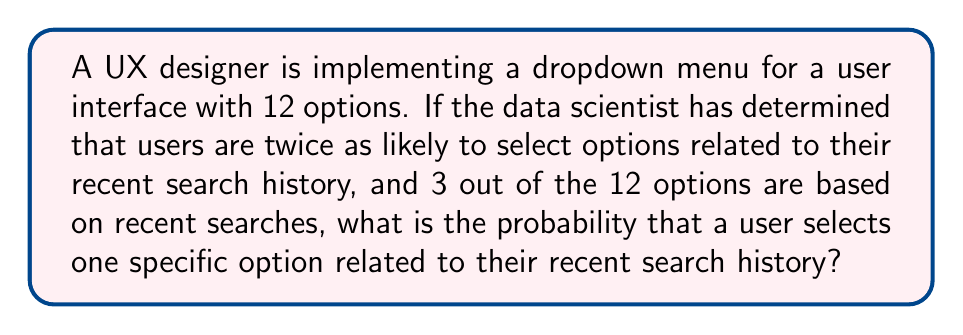Can you solve this math problem? Let's approach this step-by-step:

1) First, we need to calculate the total probability weight of all options:
   - 9 regular options: $9 \times 1 = 9$
   - 3 recent search options: $3 \times 2 = 6$
   - Total weight: $9 + 6 = 15$

2) The probability of selecting any option is its weight divided by the total weight:
   - For a regular option: $\frac{1}{15}$
   - For a recent search option: $\frac{2}{15}$

3) We're asked about the probability of selecting one specific recent search option:
   $$P(\text{specific recent search option}) = \frac{2}{15}$$

4) To verify, we can check that all probabilities sum to 1:
   $$9 \times \frac{1}{15} + 3 \times \frac{2}{15} = \frac{9}{15} + \frac{6}{15} = 1$$

Therefore, the probability of selecting one specific option related to recent search history is $\frac{2}{15}$.
Answer: $\frac{2}{15}$ 